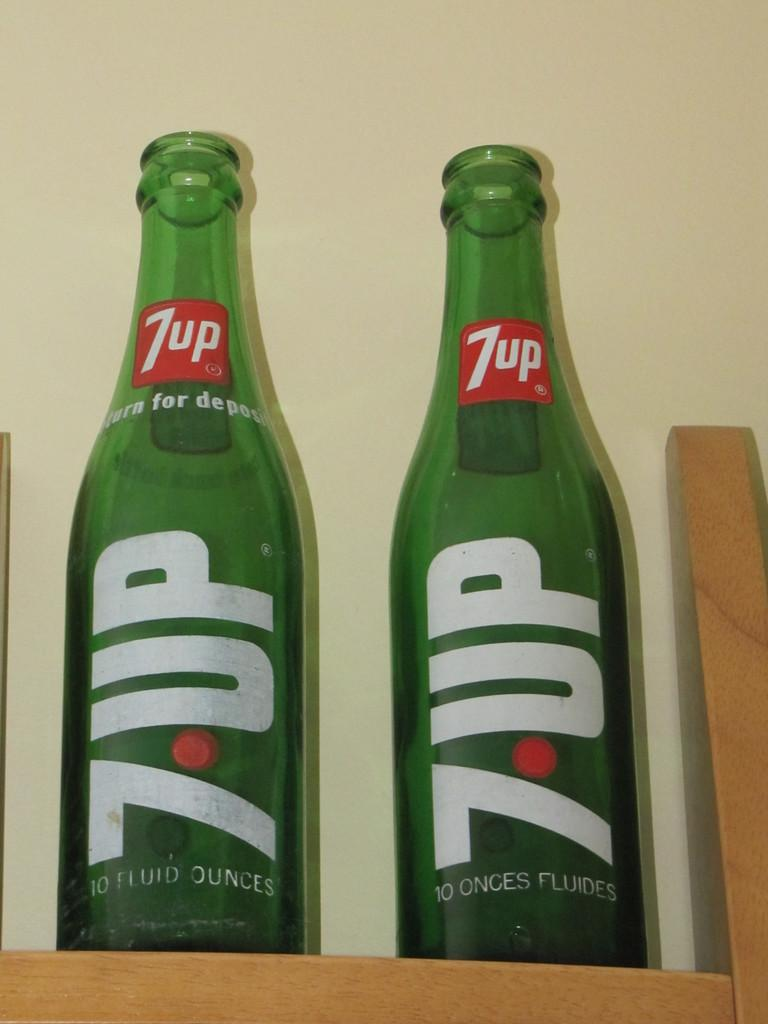<image>
Relay a brief, clear account of the picture shown. Two glass bottles of 7UP on a shelf. 